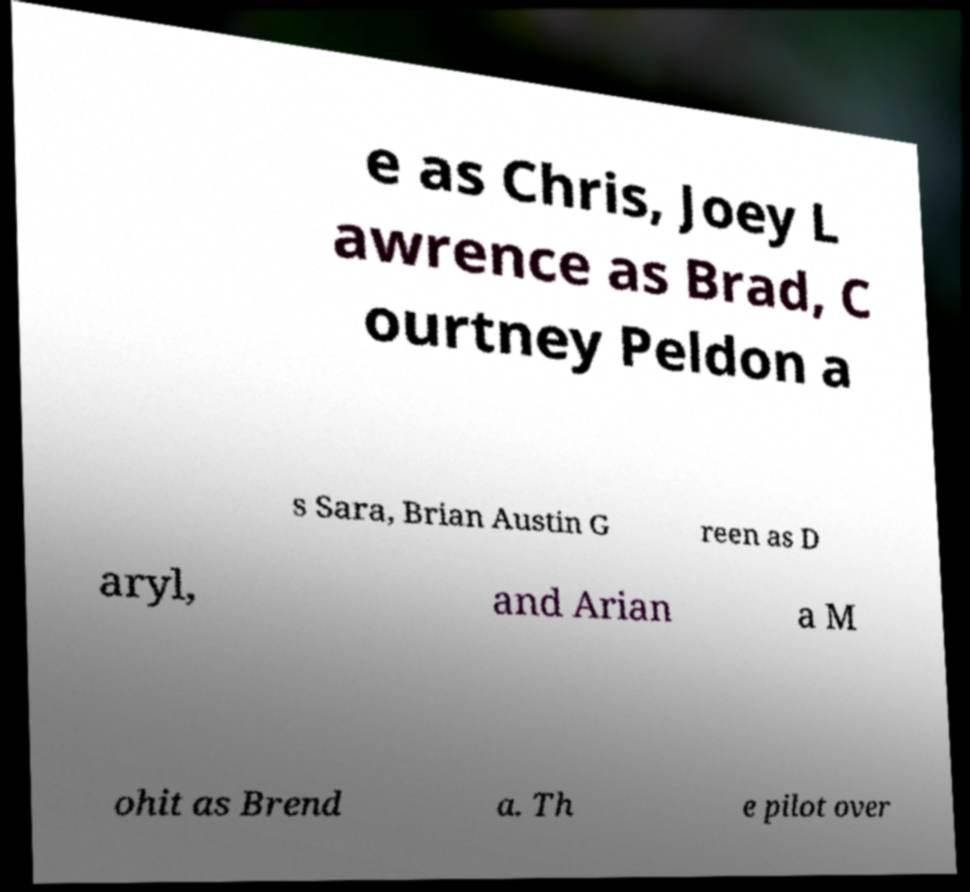Can you accurately transcribe the text from the provided image for me? e as Chris, Joey L awrence as Brad, C ourtney Peldon a s Sara, Brian Austin G reen as D aryl, and Arian a M ohit as Brend a. Th e pilot over 